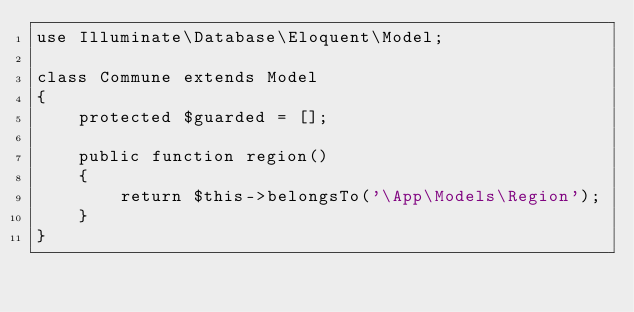<code> <loc_0><loc_0><loc_500><loc_500><_PHP_>use Illuminate\Database\Eloquent\Model;

class Commune extends Model
{
    protected $guarded = [];

    public function region()
    {
        return $this->belongsTo('\App\Models\Region');
    }
}
</code> 